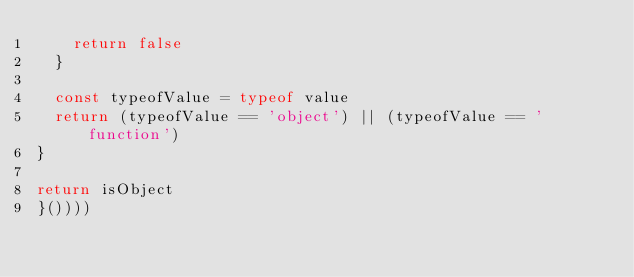Convert code to text. <code><loc_0><loc_0><loc_500><loc_500><_JavaScript_>    return false
  }

  const typeofValue = typeof value
  return (typeofValue == 'object') || (typeofValue == 'function')
}

return isObject
}())))
</code> 